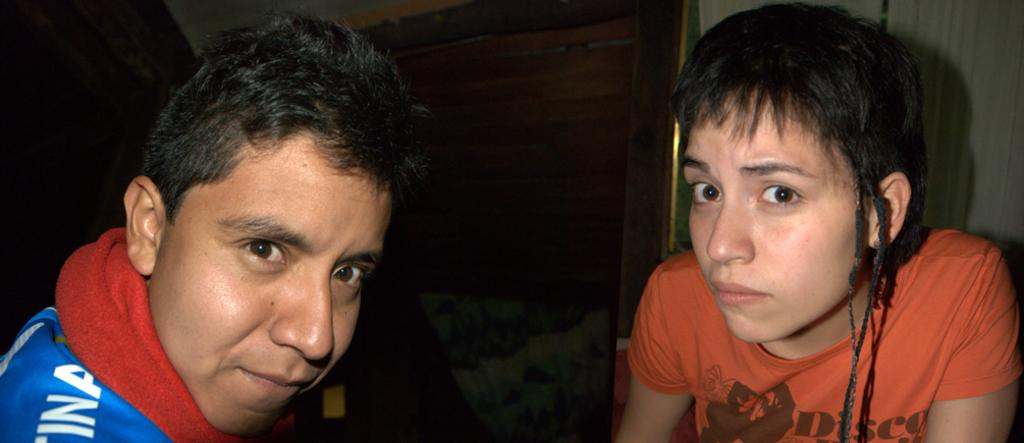How many people are present in the image? There are two people in the image. What can be seen in the background of the image? There is a wooden board and a cloth hanging in the background of the image. How many fifths are present in the image? There is no reference to a fifth in the image, so it is not possible to answer that question. 